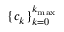Convert formula to latex. <formula><loc_0><loc_0><loc_500><loc_500>\{ c _ { k } \} _ { k = 0 } ^ { k _ { \max } }</formula> 